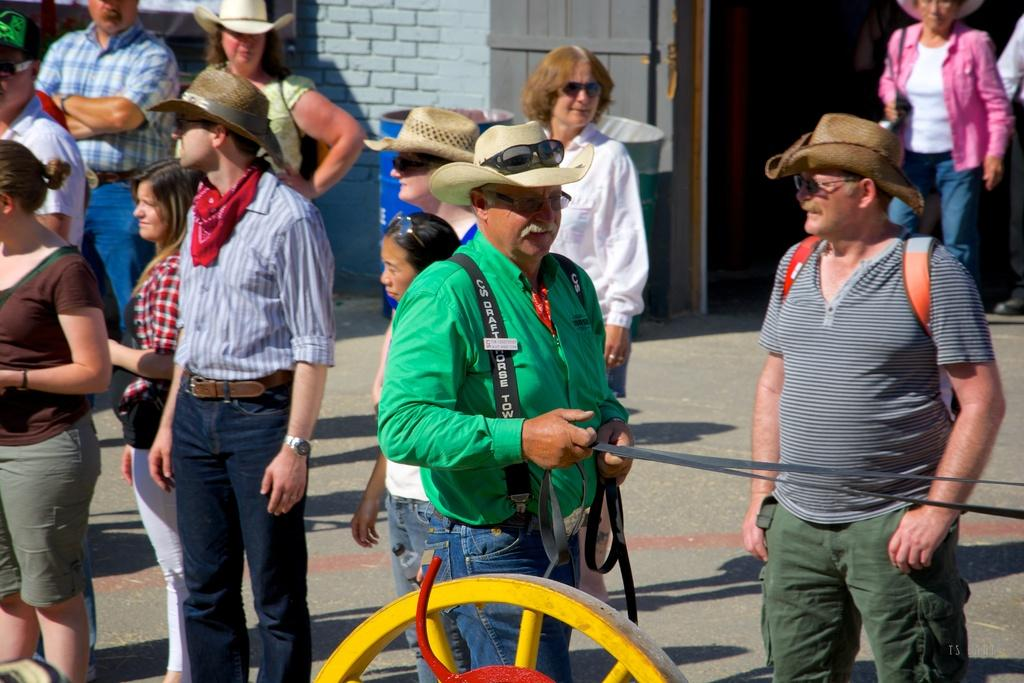What are the people in the image doing? Some people are standing on the road, and some are walking. Can you describe what one person is holding? One person is holding a thread. What can be seen in the image besides people? There is a wheel, a building, and drums in the image. How do the people in the image compare their friendship with each other? There is no information in the image about the people's friendships or any comparison being made. 